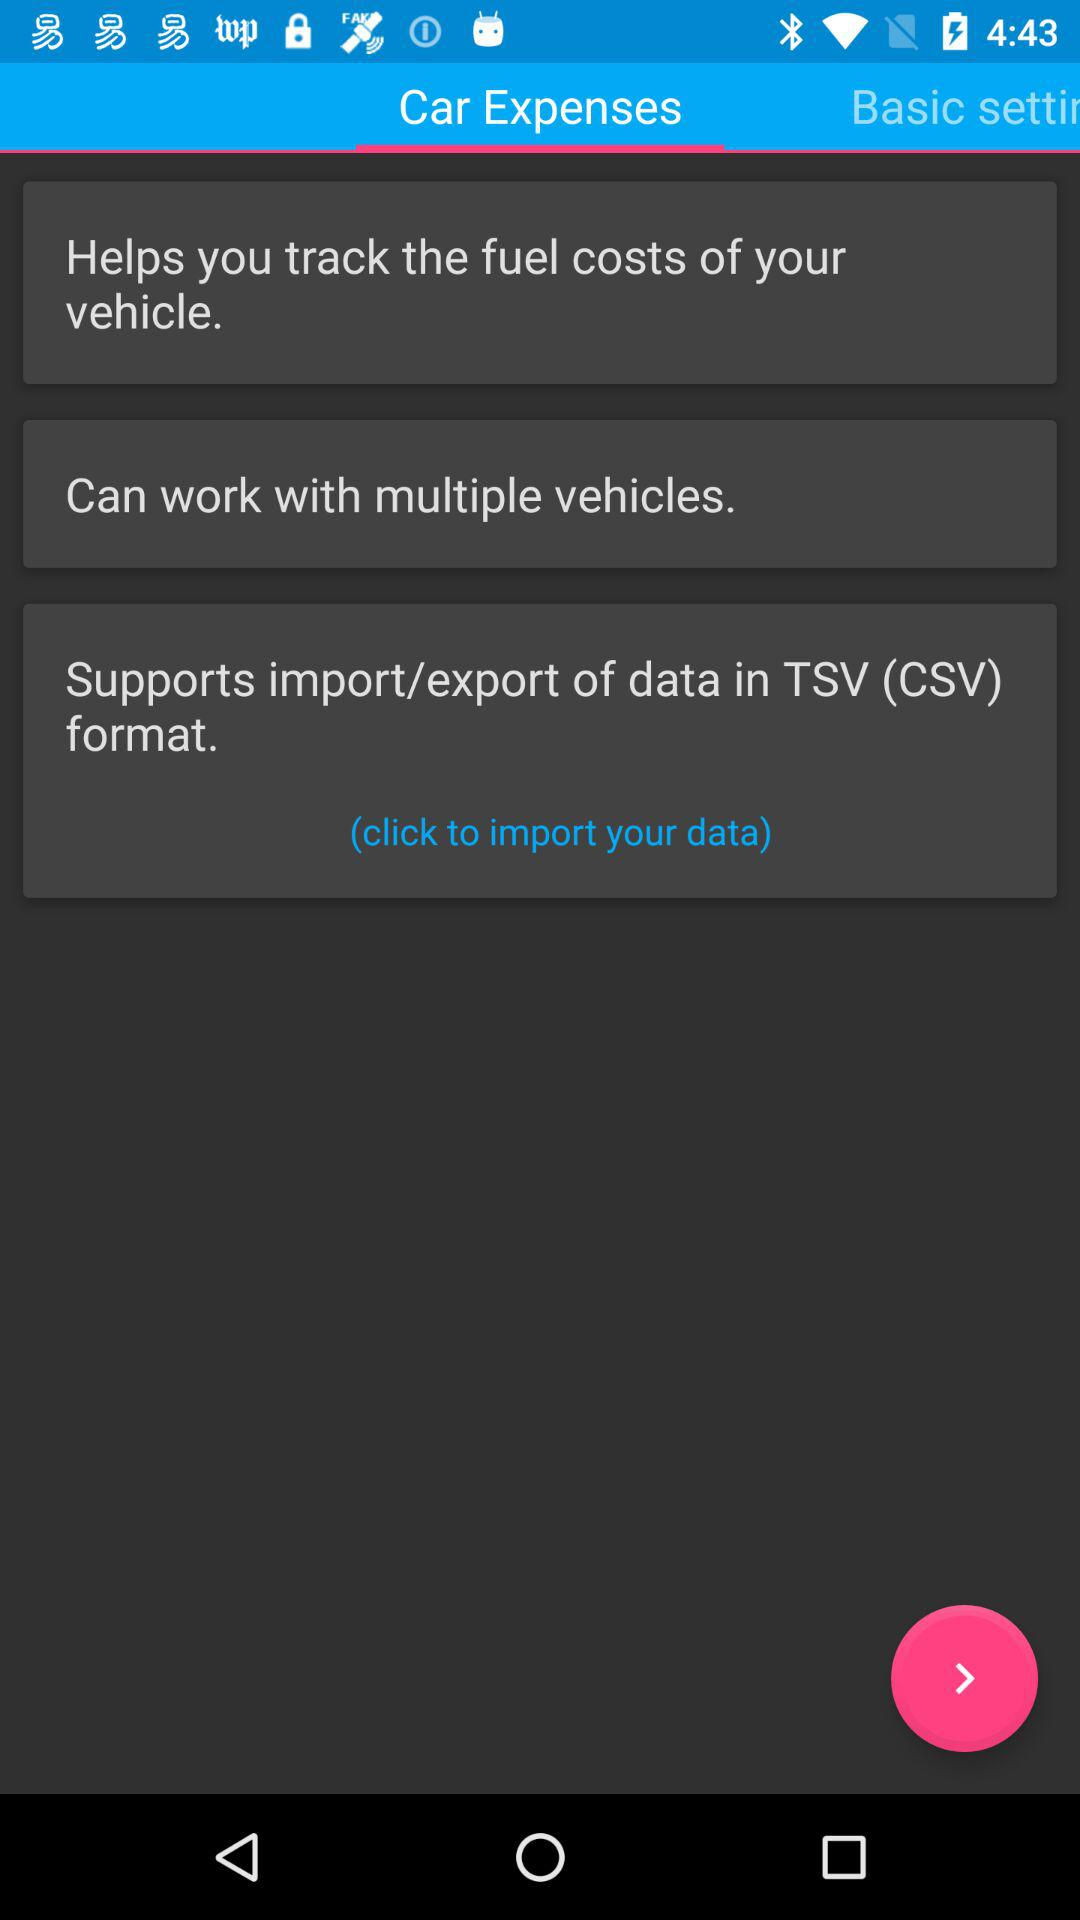Which tab is selected? The selected tab is "Car Expenses". 